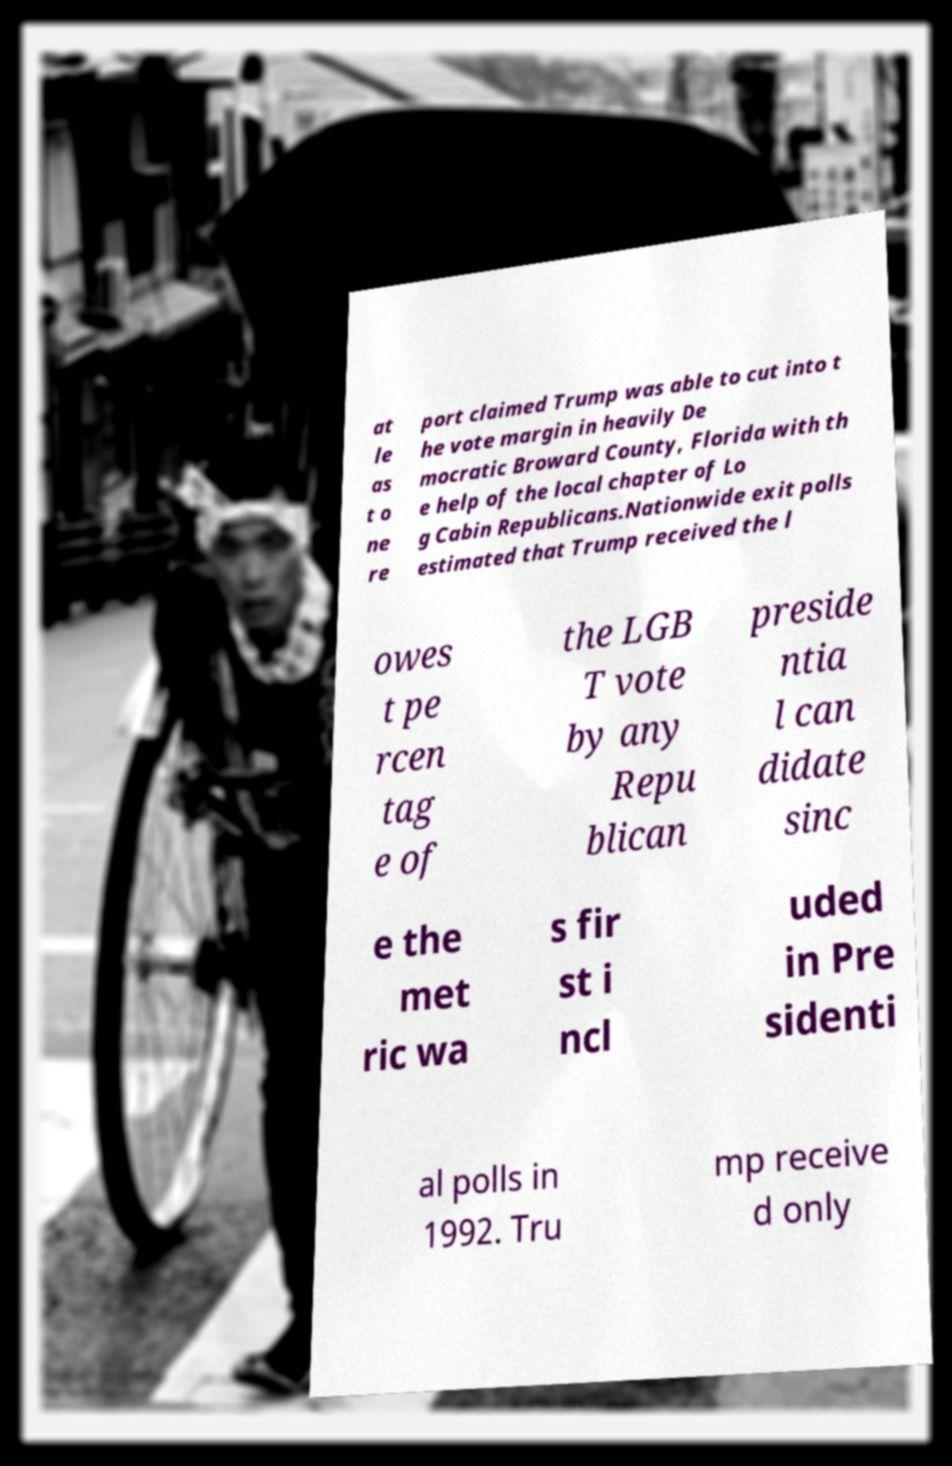Please identify and transcribe the text found in this image. at le as t o ne re port claimed Trump was able to cut into t he vote margin in heavily De mocratic Broward County, Florida with th e help of the local chapter of Lo g Cabin Republicans.Nationwide exit polls estimated that Trump received the l owes t pe rcen tag e of the LGB T vote by any Repu blican preside ntia l can didate sinc e the met ric wa s fir st i ncl uded in Pre sidenti al polls in 1992. Tru mp receive d only 